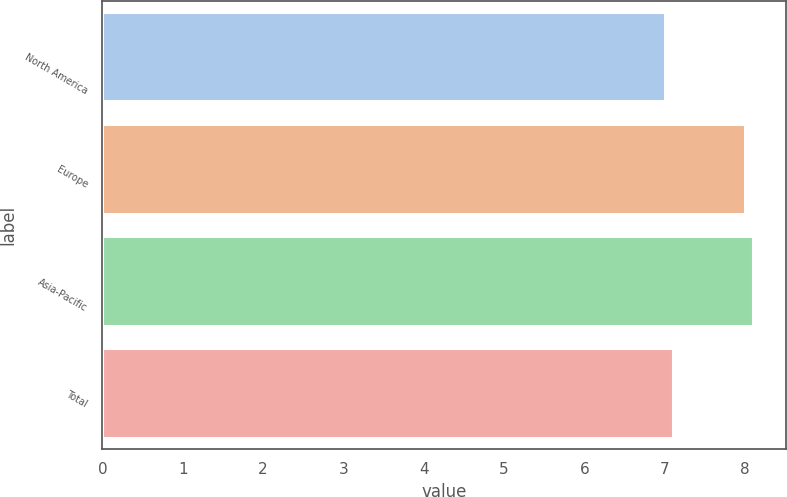Convert chart. <chart><loc_0><loc_0><loc_500><loc_500><bar_chart><fcel>North America<fcel>Europe<fcel>Asia-Pacific<fcel>Total<nl><fcel>7<fcel>8<fcel>8.1<fcel>7.1<nl></chart> 